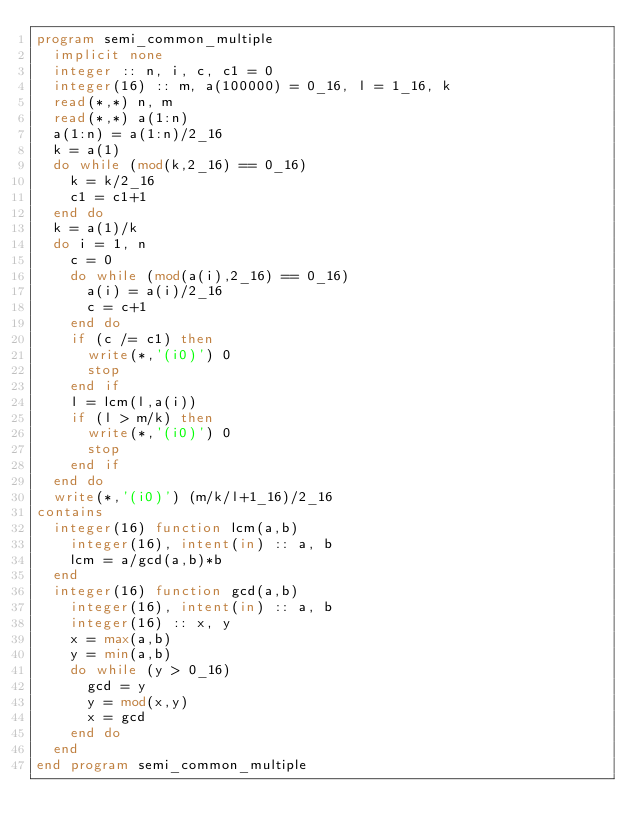<code> <loc_0><loc_0><loc_500><loc_500><_FORTRAN_>program semi_common_multiple
  implicit none
  integer :: n, i, c, c1 = 0
  integer(16) :: m, a(100000) = 0_16, l = 1_16, k
  read(*,*) n, m
  read(*,*) a(1:n)
  a(1:n) = a(1:n)/2_16
  k = a(1)
  do while (mod(k,2_16) == 0_16)
    k = k/2_16
    c1 = c1+1
  end do
  k = a(1)/k
  do i = 1, n
    c = 0
    do while (mod(a(i),2_16) == 0_16)
      a(i) = a(i)/2_16
      c = c+1
    end do
    if (c /= c1) then
      write(*,'(i0)') 0
      stop
    end if
    l = lcm(l,a(i))
    if (l > m/k) then
      write(*,'(i0)') 0
      stop
    end if
  end do
  write(*,'(i0)') (m/k/l+1_16)/2_16
contains
  integer(16) function lcm(a,b)
    integer(16), intent(in) :: a, b
    lcm = a/gcd(a,b)*b
  end
  integer(16) function gcd(a,b)
    integer(16), intent(in) :: a, b
    integer(16) :: x, y
    x = max(a,b)
    y = min(a,b)
    do while (y > 0_16)
      gcd = y
      y = mod(x,y)
      x = gcd
    end do
  end
end program semi_common_multiple</code> 